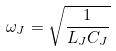Convert formula to latex. <formula><loc_0><loc_0><loc_500><loc_500>\omega _ { J } = \sqrt { \frac { 1 } { L _ { J } C _ { J } } }</formula> 